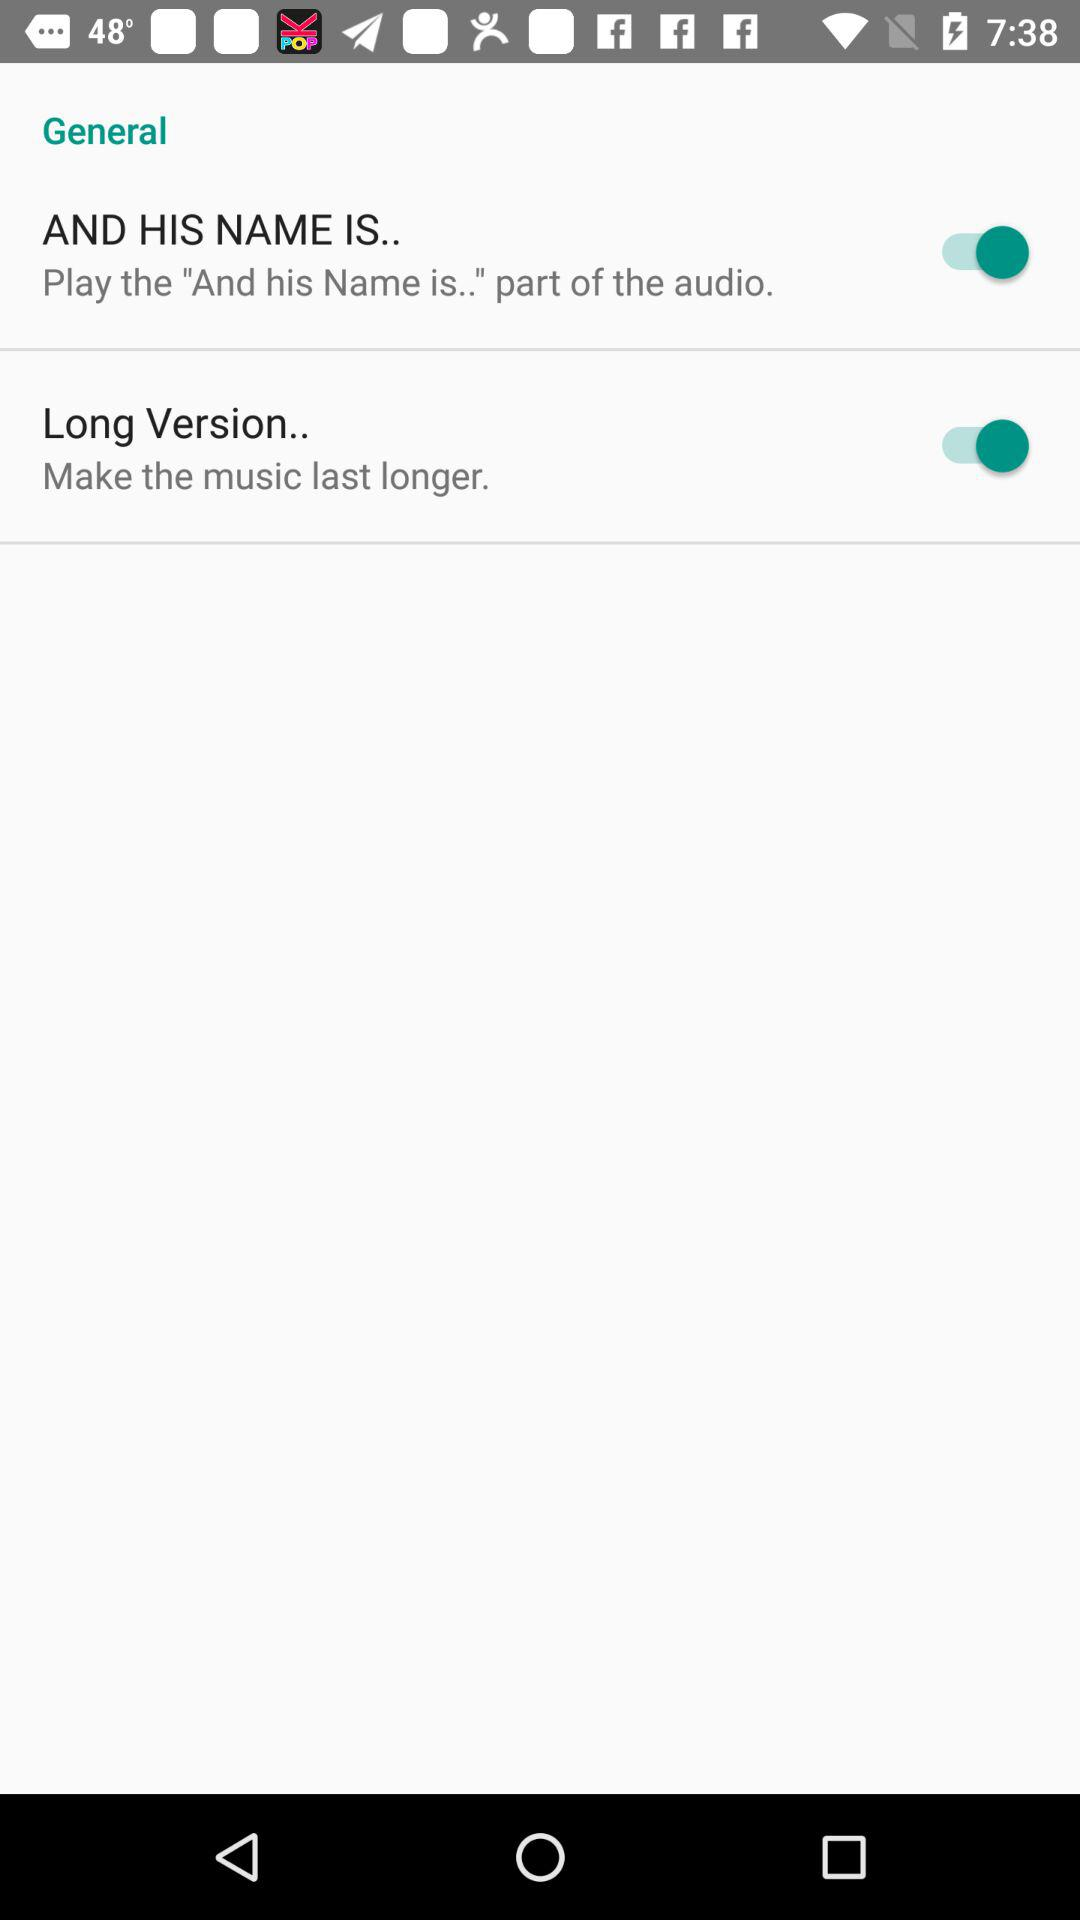What is the status of "Long Version.."? The status of "Long Version.." is "on". 